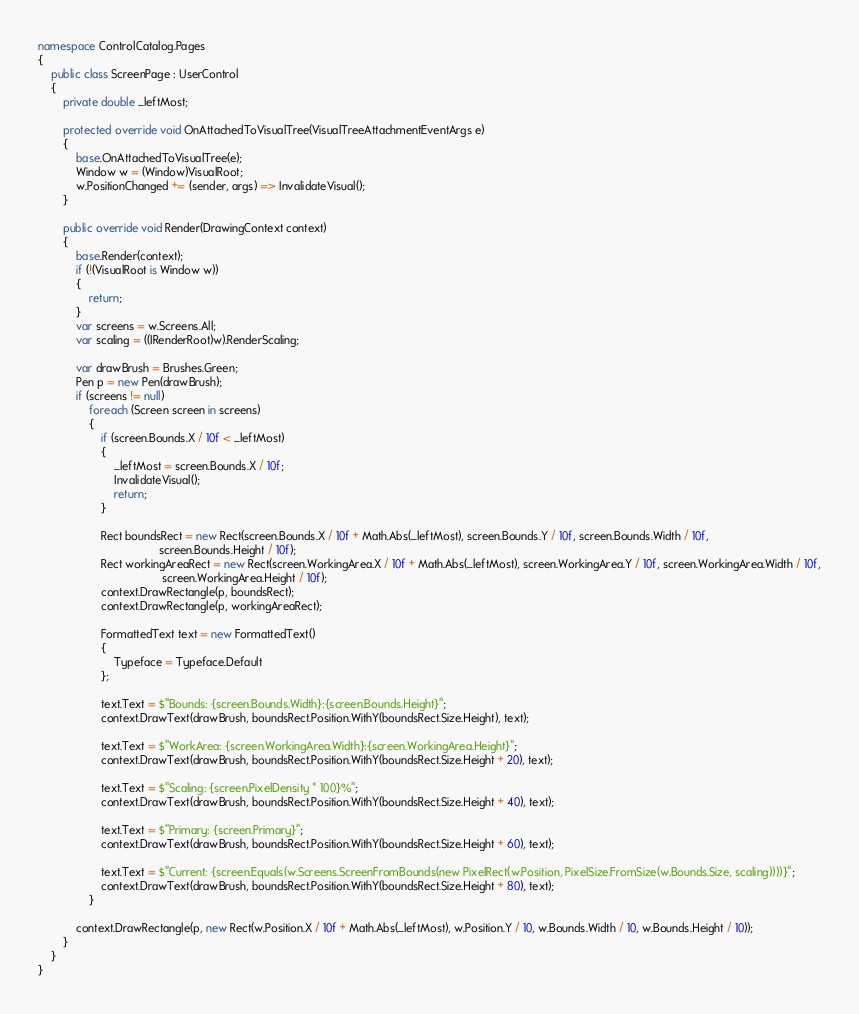<code> <loc_0><loc_0><loc_500><loc_500><_C#_>
namespace ControlCatalog.Pages
{
    public class ScreenPage : UserControl
    {
        private double _leftMost;

        protected override void OnAttachedToVisualTree(VisualTreeAttachmentEventArgs e)
        {
            base.OnAttachedToVisualTree(e);
            Window w = (Window)VisualRoot;
            w.PositionChanged += (sender, args) => InvalidateVisual();
        }

        public override void Render(DrawingContext context)
        {
            base.Render(context);
            if (!(VisualRoot is Window w))
            {
                return;                
            }
            var screens = w.Screens.All;
            var scaling = ((IRenderRoot)w).RenderScaling;

            var drawBrush = Brushes.Green;
            Pen p = new Pen(drawBrush);
            if (screens != null)
                foreach (Screen screen in screens)
                {
                    if (screen.Bounds.X / 10f < _leftMost)
                    {
                        _leftMost = screen.Bounds.X / 10f;
                        InvalidateVisual();
                        return;
                    }

                    Rect boundsRect = new Rect(screen.Bounds.X / 10f + Math.Abs(_leftMost), screen.Bounds.Y / 10f, screen.Bounds.Width / 10f,
                                      screen.Bounds.Height / 10f);
                    Rect workingAreaRect = new Rect(screen.WorkingArea.X / 10f + Math.Abs(_leftMost), screen.WorkingArea.Y / 10f, screen.WorkingArea.Width / 10f,
                                       screen.WorkingArea.Height / 10f);
                    context.DrawRectangle(p, boundsRect);
                    context.DrawRectangle(p, workingAreaRect);
                    
                    FormattedText text = new FormattedText()
                    {
                        Typeface = Typeface.Default
                    };

                    text.Text = $"Bounds: {screen.Bounds.Width}:{screen.Bounds.Height}";
                    context.DrawText(drawBrush, boundsRect.Position.WithY(boundsRect.Size.Height), text);
                    
                    text.Text = $"WorkArea: {screen.WorkingArea.Width}:{screen.WorkingArea.Height}";
                    context.DrawText(drawBrush, boundsRect.Position.WithY(boundsRect.Size.Height + 20), text);

                    text.Text = $"Scaling: {screen.PixelDensity * 100}%";
                    context.DrawText(drawBrush, boundsRect.Position.WithY(boundsRect.Size.Height + 40), text);
                    
                    text.Text = $"Primary: {screen.Primary}";
                    context.DrawText(drawBrush, boundsRect.Position.WithY(boundsRect.Size.Height + 60), text);
                    
                    text.Text = $"Current: {screen.Equals(w.Screens.ScreenFromBounds(new PixelRect(w.Position, PixelSize.FromSize(w.Bounds.Size, scaling))))}";
                    context.DrawText(drawBrush, boundsRect.Position.WithY(boundsRect.Size.Height + 80), text);
                }

            context.DrawRectangle(p, new Rect(w.Position.X / 10f + Math.Abs(_leftMost), w.Position.Y / 10, w.Bounds.Width / 10, w.Bounds.Height / 10));
        }
    }
}
</code> 